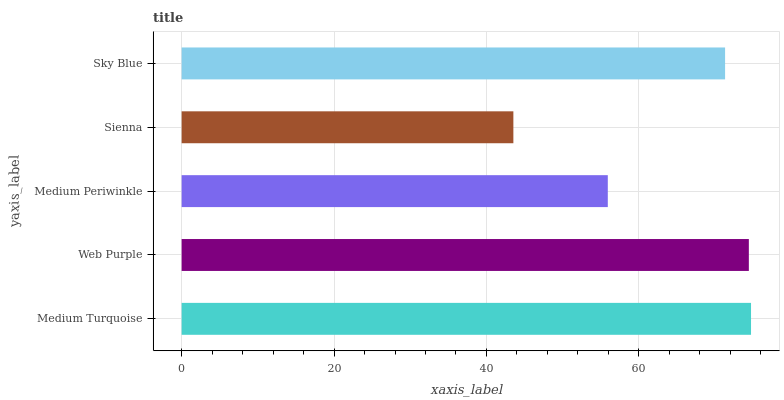Is Sienna the minimum?
Answer yes or no. Yes. Is Medium Turquoise the maximum?
Answer yes or no. Yes. Is Web Purple the minimum?
Answer yes or no. No. Is Web Purple the maximum?
Answer yes or no. No. Is Medium Turquoise greater than Web Purple?
Answer yes or no. Yes. Is Web Purple less than Medium Turquoise?
Answer yes or no. Yes. Is Web Purple greater than Medium Turquoise?
Answer yes or no. No. Is Medium Turquoise less than Web Purple?
Answer yes or no. No. Is Sky Blue the high median?
Answer yes or no. Yes. Is Sky Blue the low median?
Answer yes or no. Yes. Is Sienna the high median?
Answer yes or no. No. Is Medium Periwinkle the low median?
Answer yes or no. No. 